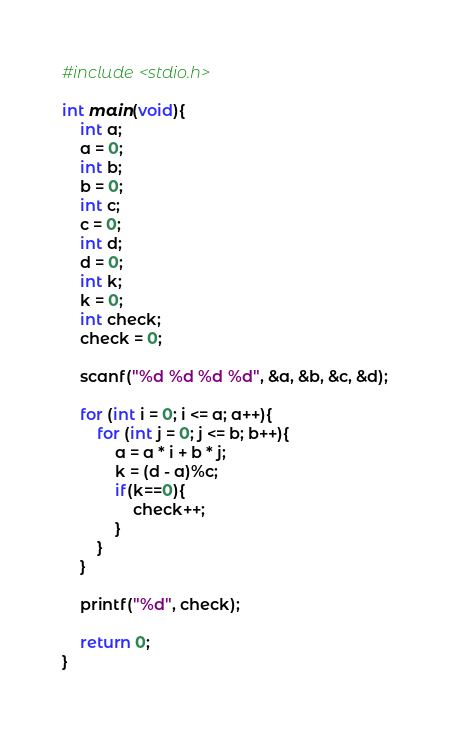Convert code to text. <code><loc_0><loc_0><loc_500><loc_500><_C_>#include <stdio.h>

int main(void){
    int a;
    a = 0;
    int b;
    b = 0;
    int c;
    c = 0;
    int d;
    d = 0;
    int k;
    k = 0;
    int check;
    check = 0;

    scanf("%d %d %d %d", &a, &b, &c, &d);
    
    for (int i = 0; i <= a; a++){
        for (int j = 0; j <= b; b++){
            a = a * i + b * j;
            k = (d - a)%c;
            if(k==0){
                check++;
            }
        }
    }

    printf("%d", check);

    return 0;
}</code> 